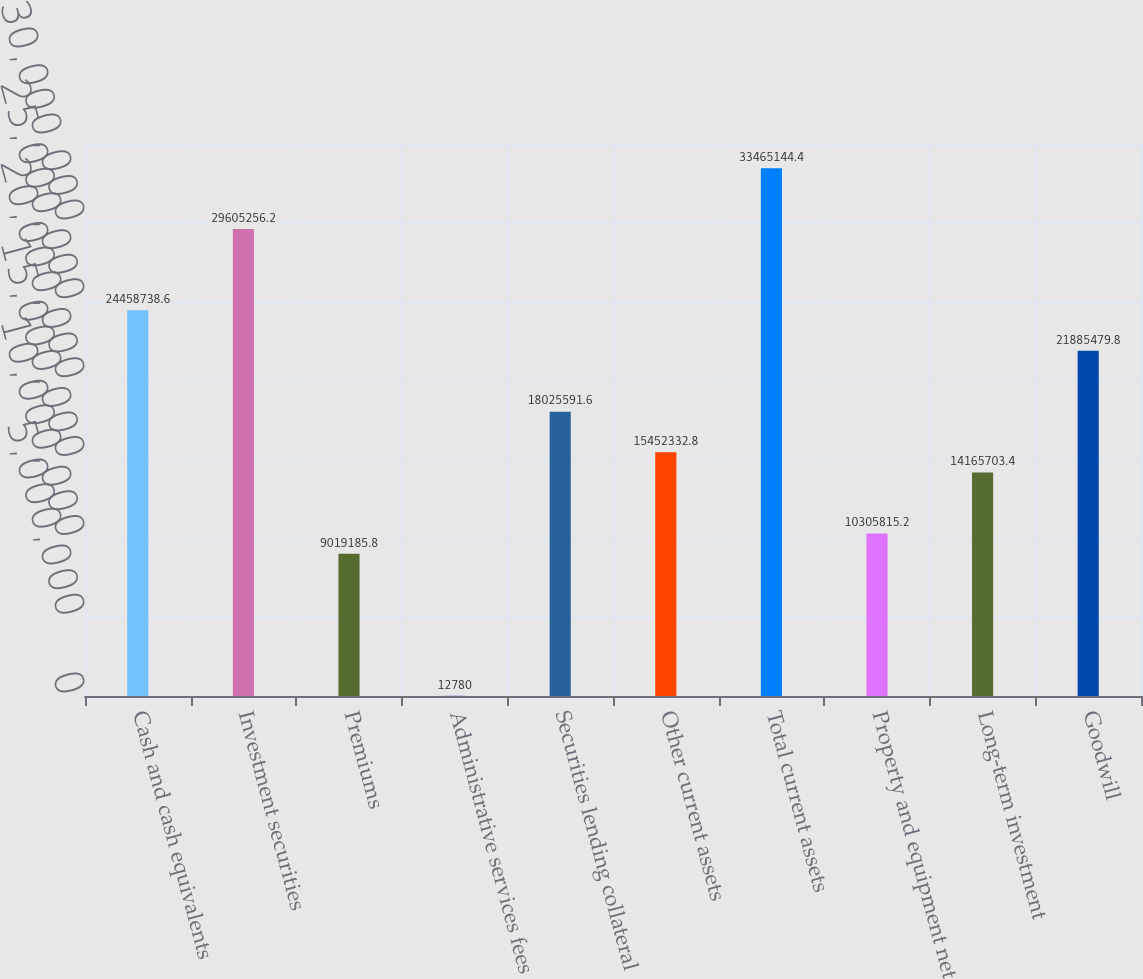<chart> <loc_0><loc_0><loc_500><loc_500><bar_chart><fcel>Cash and cash equivalents<fcel>Investment securities<fcel>Premiums<fcel>Administrative services fees<fcel>Securities lending collateral<fcel>Other current assets<fcel>Total current assets<fcel>Property and equipment net<fcel>Long-term investment<fcel>Goodwill<nl><fcel>2.44587e+07<fcel>2.96053e+07<fcel>9.01919e+06<fcel>12780<fcel>1.80256e+07<fcel>1.54523e+07<fcel>3.34651e+07<fcel>1.03058e+07<fcel>1.41657e+07<fcel>2.18855e+07<nl></chart> 